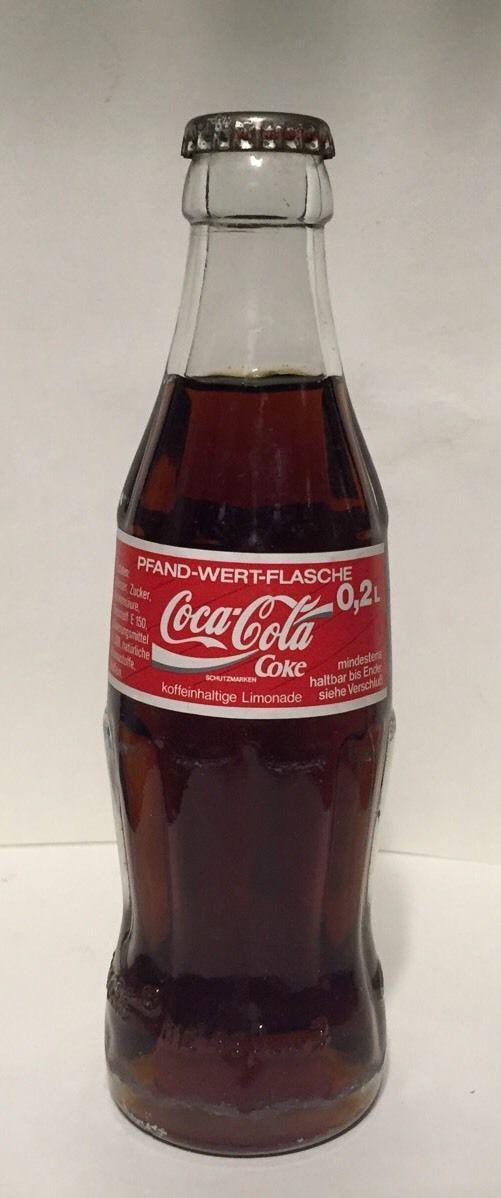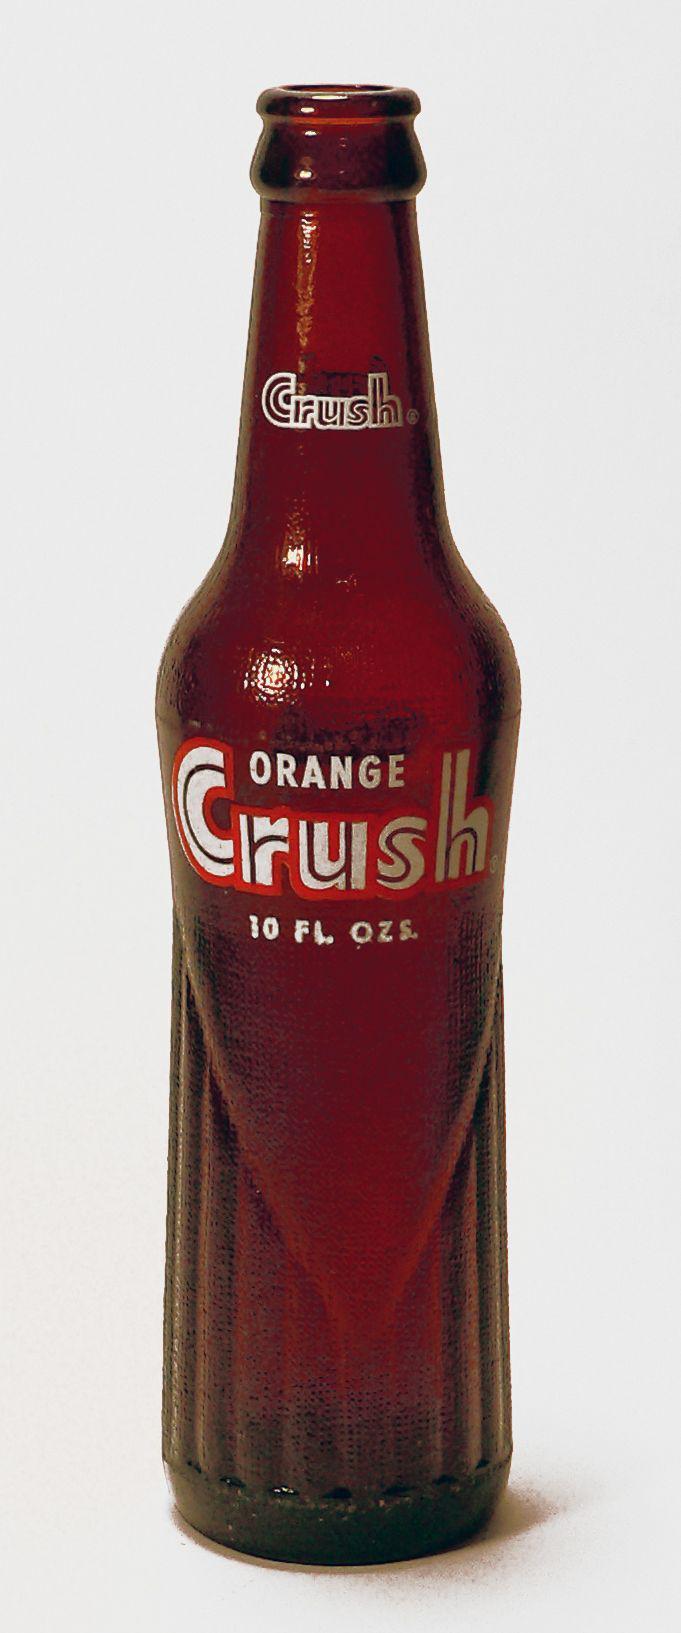The first image is the image on the left, the second image is the image on the right. Given the left and right images, does the statement "Each image shows one bottle with a cap on it, and one image features a bottle that tapers from its base, has a textured surface but no label, and contains a red liquid." hold true? Answer yes or no. No. The first image is the image on the left, the second image is the image on the right. Assess this claim about the two images: "There are labels on each of the bottles.". Correct or not? Answer yes or no. Yes. 